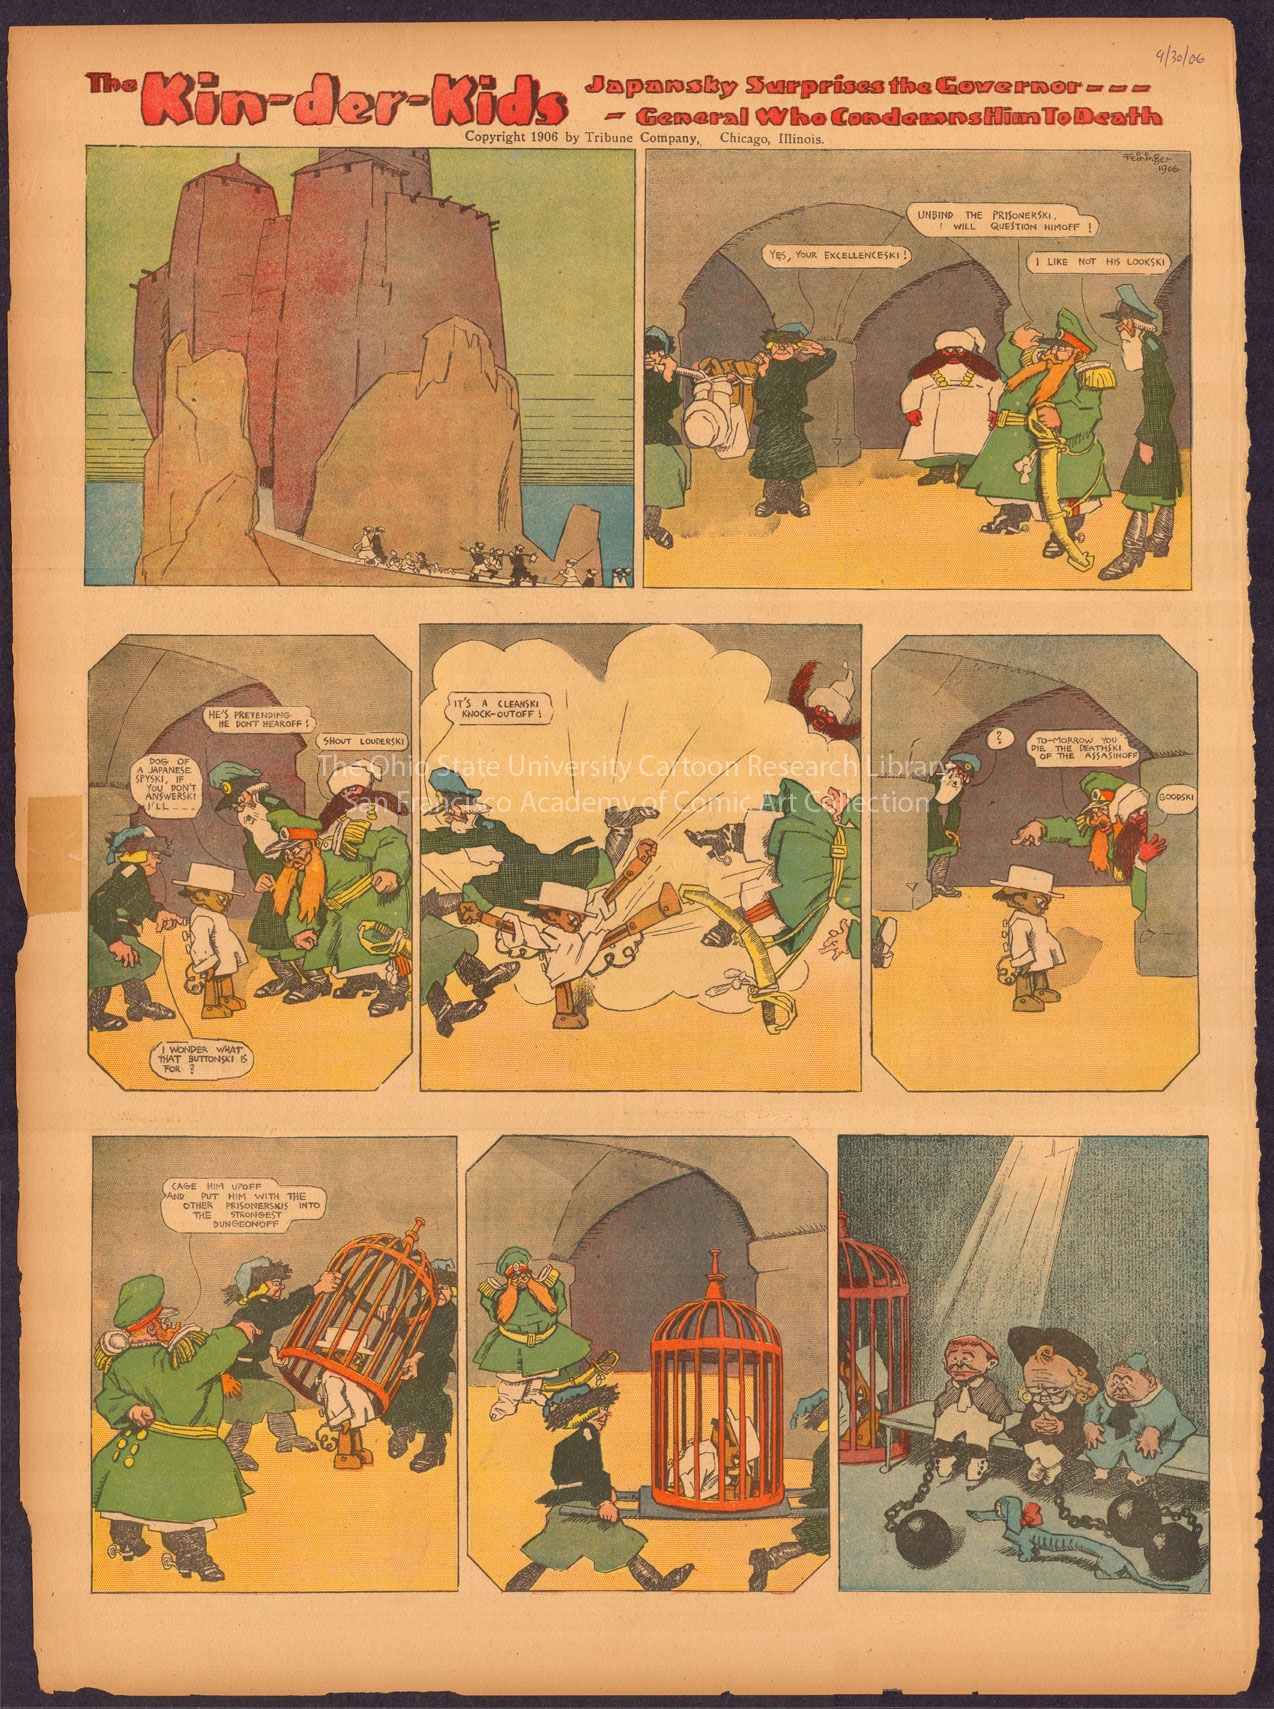How would you describe the art style of this comic strip? The art style of 'The Kin-der-Kids' comic strip is typical of the early 20th century, featuring exaggerated expressions and physical features to convey humor and emotion. Bold outlines and flat areas of color are used, along with dynamic compositions that give a sense of movement and energy. The panel layouts are creative, pushing the boundaries of traditional square frames, and propelling the story forward through both visual and textual content. 